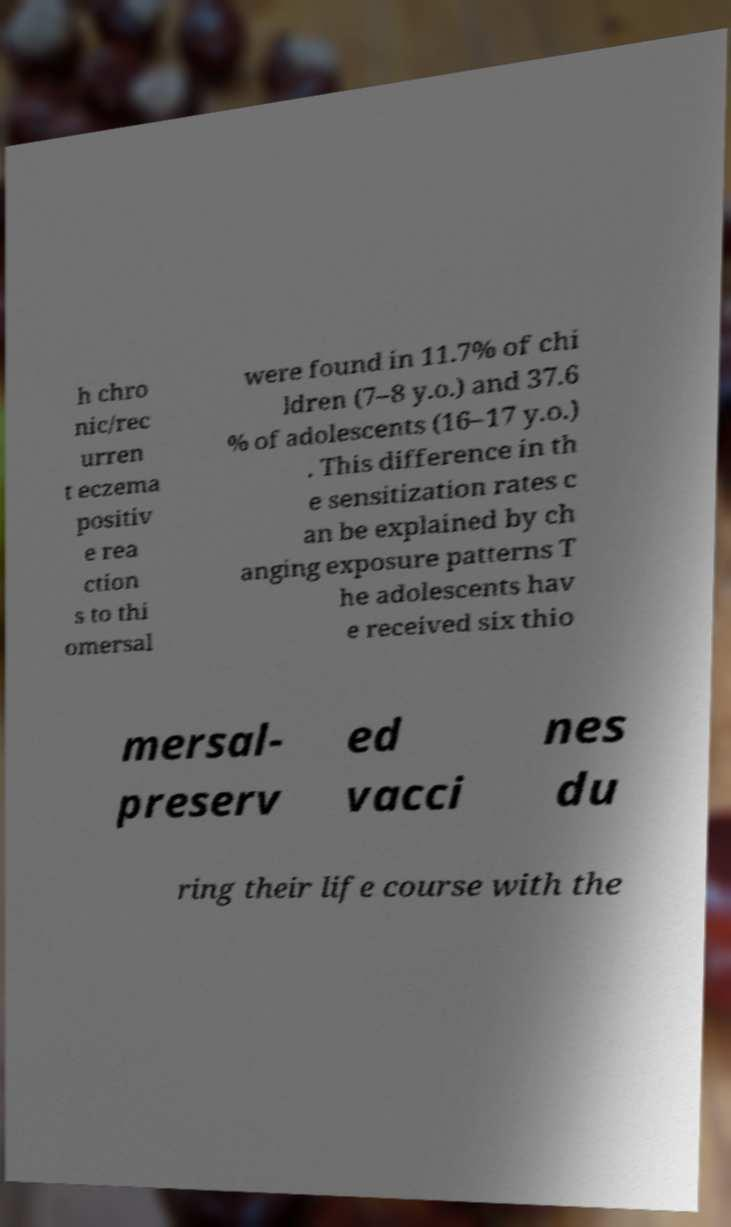There's text embedded in this image that I need extracted. Can you transcribe it verbatim? h chro nic/rec urren t eczema positiv e rea ction s to thi omersal were found in 11.7% of chi ldren (7–8 y.o.) and 37.6 % of adolescents (16–17 y.o.) . This difference in th e sensitization rates c an be explained by ch anging exposure patterns T he adolescents hav e received six thio mersal- preserv ed vacci nes du ring their life course with the 